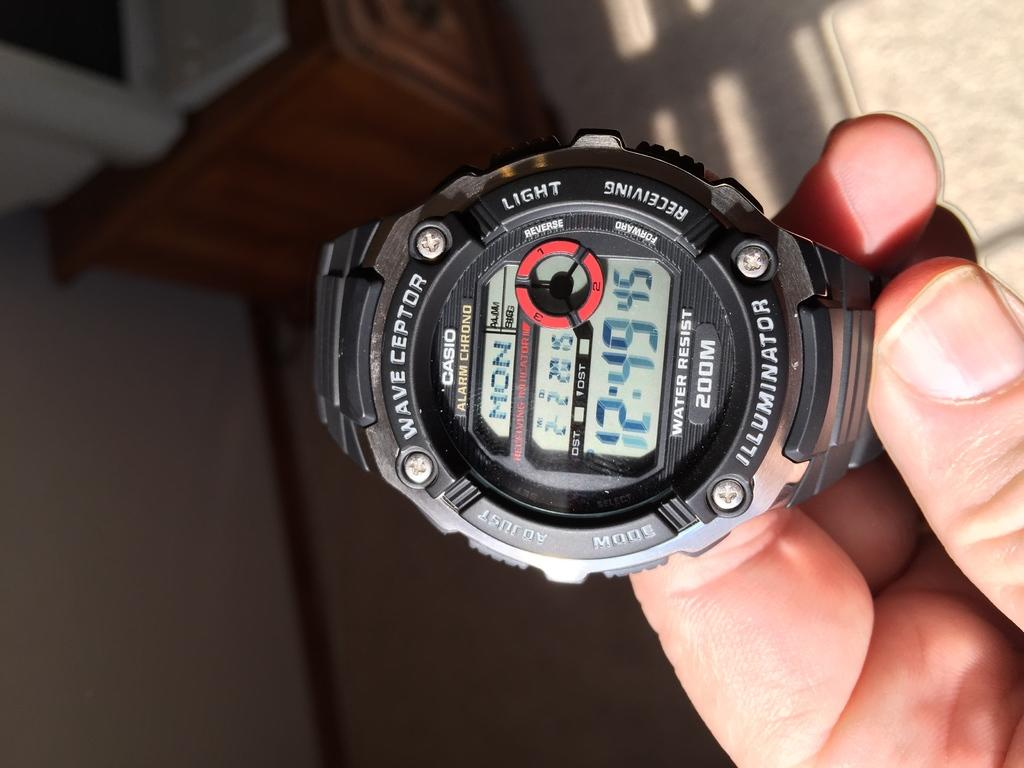What is the main subject of the image? The main subject of the image is a human hand holding a watch. Can you describe the watch in the image? The watch is black in color. What can be seen in the background of the image? There is a wooden object and a few other objects in the background. How many brothers can be seen in the image? There are no brothers present in the image; it features a human hand holding a watch. What type of straw is being used by the person in the image? There is no person or straw present in the image. 